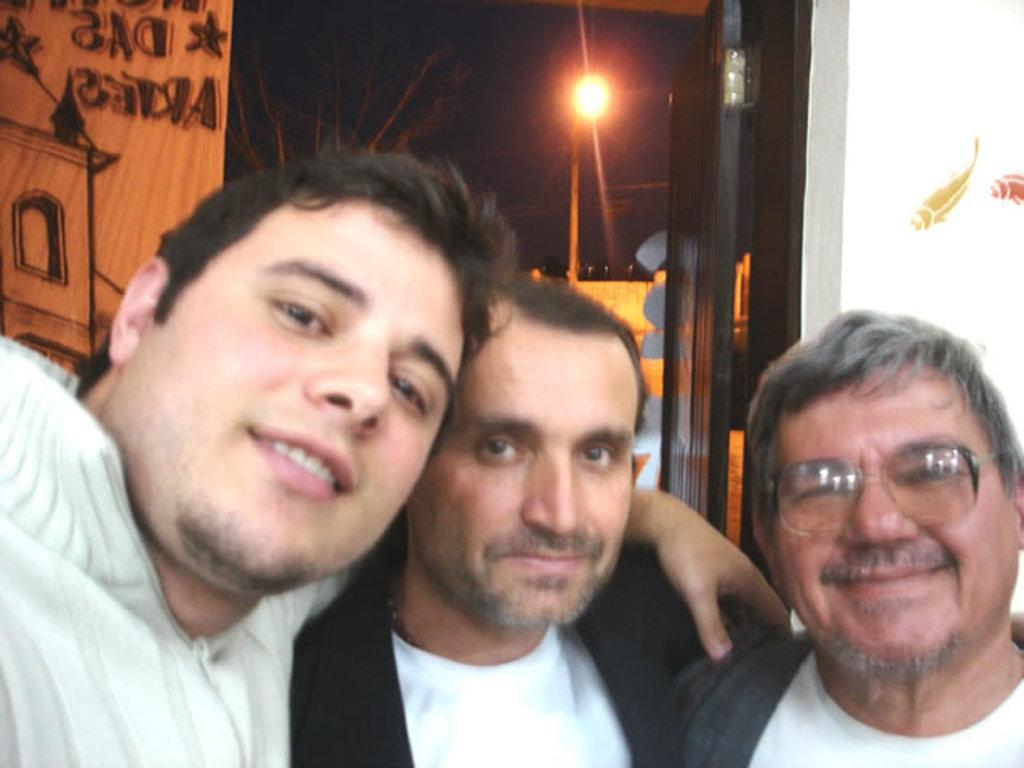What are the people in the image doing? The persons standing at the door in the image suggest they might be waiting or about to enter. What can be seen in the background of the image? There is a tree, light, a door, a building, and the sky visible in the background of the image. How many doors are visible in the image? There is one door visible in the image, which is in the background. What type of egg is being used as a protest symbol in the image? There is no egg or protest symbol present in the image. Can you tell me where the library is located in the image? There is no library visible in the image. 